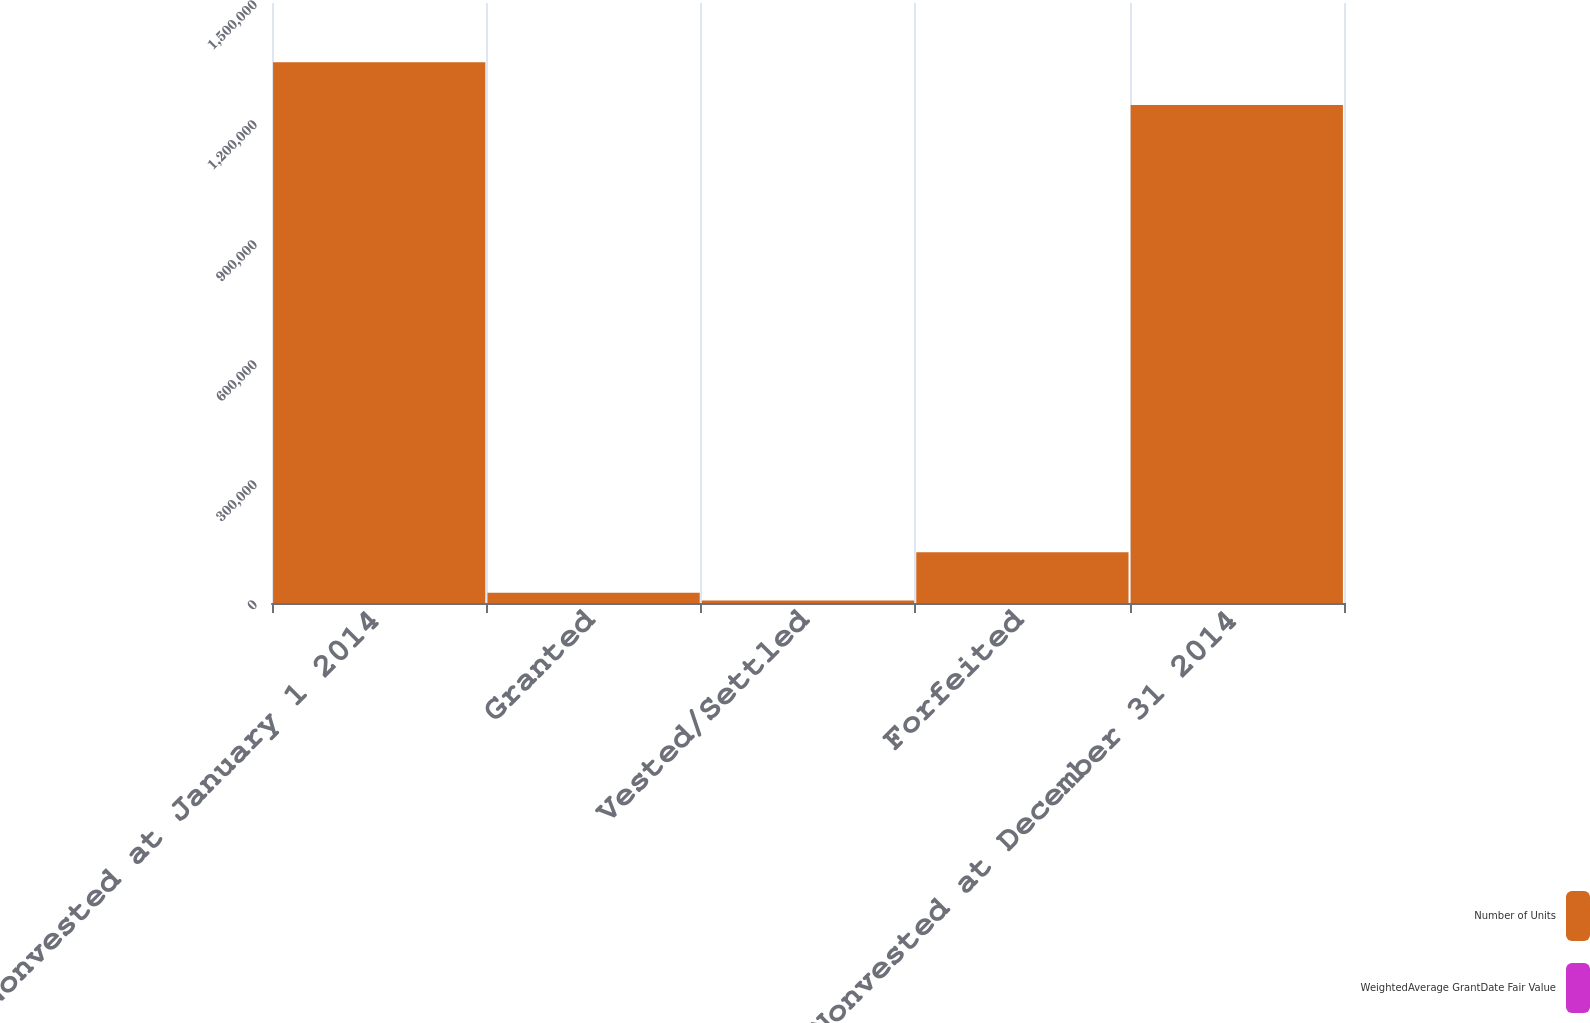Convert chart. <chart><loc_0><loc_0><loc_500><loc_500><stacked_bar_chart><ecel><fcel>Nonvested at January 1 2014<fcel>Granted<fcel>Vested/Settled<fcel>Forfeited<fcel>Nonvested at December 31 2014<nl><fcel>Number of Units<fcel>1.35157e+06<fcel>25895<fcel>5984<fcel>126781<fcel>1.2447e+06<nl><fcel>WeightedAverage GrantDate Fair Value<fcel>17.04<fcel>24.29<fcel>17<fcel>17.04<fcel>17.19<nl></chart> 